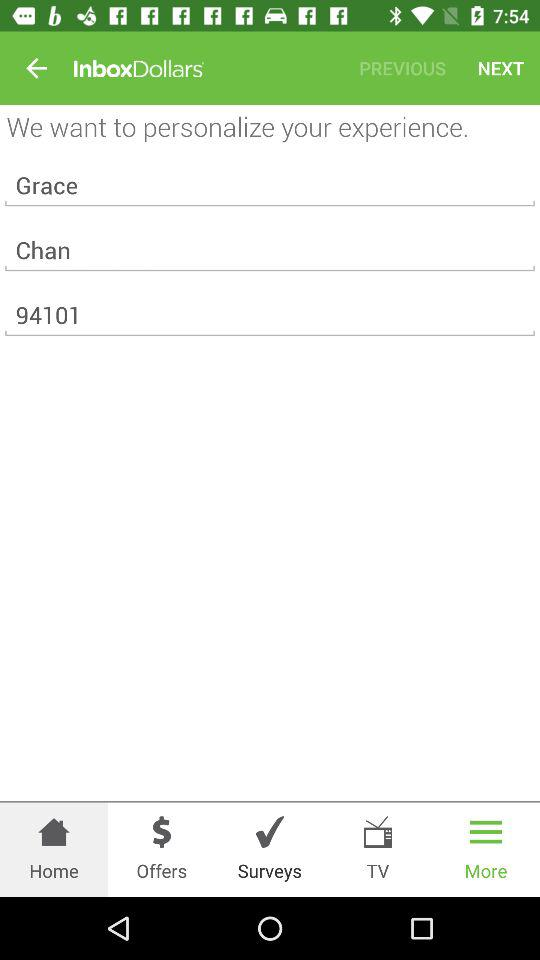What is the name of the user? The name of the user is Grace Chan. 